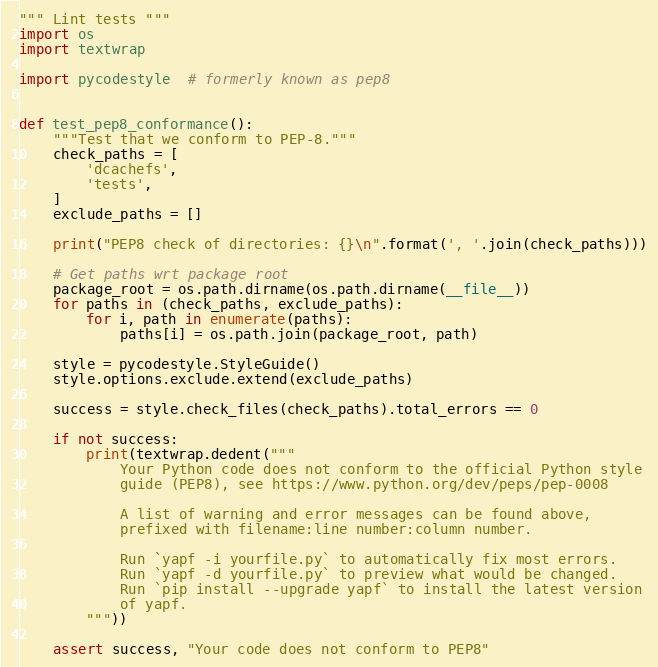Convert code to text. <code><loc_0><loc_0><loc_500><loc_500><_Python_>""" Lint tests """
import os
import textwrap

import pycodestyle  # formerly known as pep8


def test_pep8_conformance():
    """Test that we conform to PEP-8."""
    check_paths = [
        'dcachefs',
        'tests',
    ]
    exclude_paths = []

    print("PEP8 check of directories: {}\n".format(', '.join(check_paths)))

    # Get paths wrt package root
    package_root = os.path.dirname(os.path.dirname(__file__))
    for paths in (check_paths, exclude_paths):
        for i, path in enumerate(paths):
            paths[i] = os.path.join(package_root, path)

    style = pycodestyle.StyleGuide()
    style.options.exclude.extend(exclude_paths)

    success = style.check_files(check_paths).total_errors == 0

    if not success:
        print(textwrap.dedent("""
            Your Python code does not conform to the official Python style
            guide (PEP8), see https://www.python.org/dev/peps/pep-0008

            A list of warning and error messages can be found above,
            prefixed with filename:line number:column number.

            Run `yapf -i yourfile.py` to automatically fix most errors.
            Run `yapf -d yourfile.py` to preview what would be changed.
            Run `pip install --upgrade yapf` to install the latest version
            of yapf.
        """))

    assert success, "Your code does not conform to PEP8"
</code> 